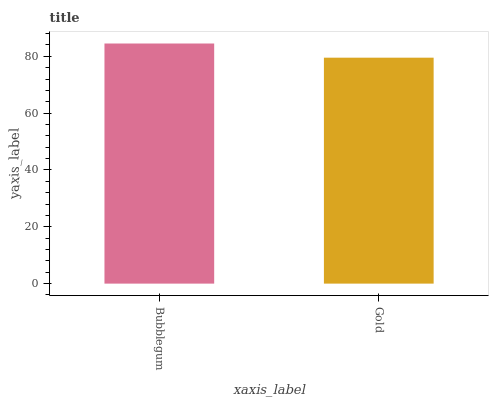Is Gold the minimum?
Answer yes or no. Yes. Is Bubblegum the maximum?
Answer yes or no. Yes. Is Gold the maximum?
Answer yes or no. No. Is Bubblegum greater than Gold?
Answer yes or no. Yes. Is Gold less than Bubblegum?
Answer yes or no. Yes. Is Gold greater than Bubblegum?
Answer yes or no. No. Is Bubblegum less than Gold?
Answer yes or no. No. Is Bubblegum the high median?
Answer yes or no. Yes. Is Gold the low median?
Answer yes or no. Yes. Is Gold the high median?
Answer yes or no. No. Is Bubblegum the low median?
Answer yes or no. No. 